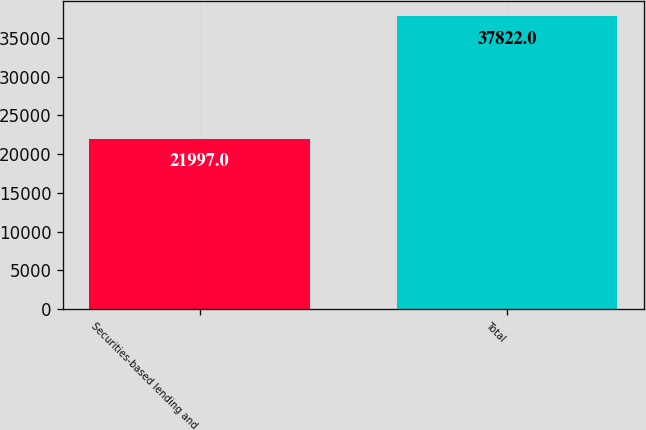Convert chart to OTSL. <chart><loc_0><loc_0><loc_500><loc_500><bar_chart><fcel>Securities-based lending and<fcel>Total<nl><fcel>21997<fcel>37822<nl></chart> 